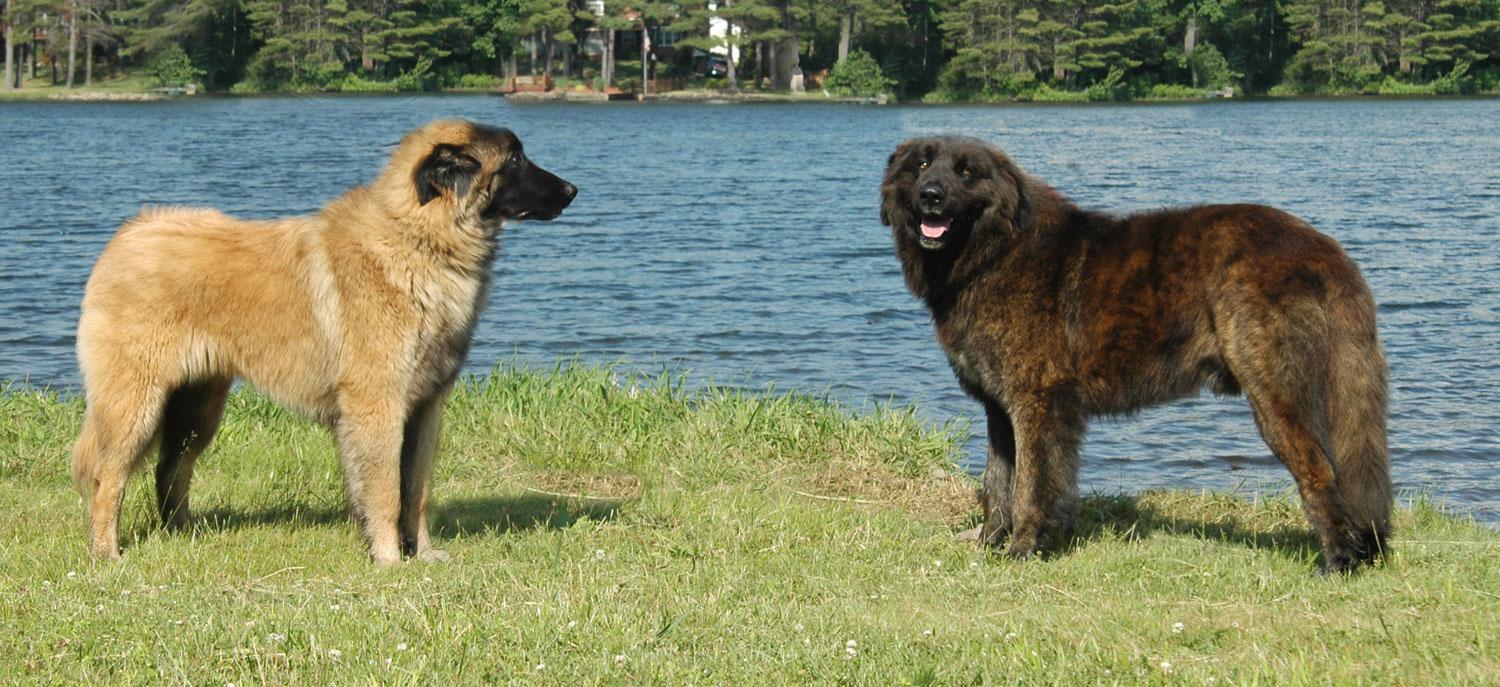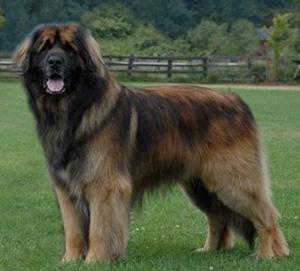The first image is the image on the left, the second image is the image on the right. Considering the images on both sides, is "There are three dogs." valid? Answer yes or no. Yes. 